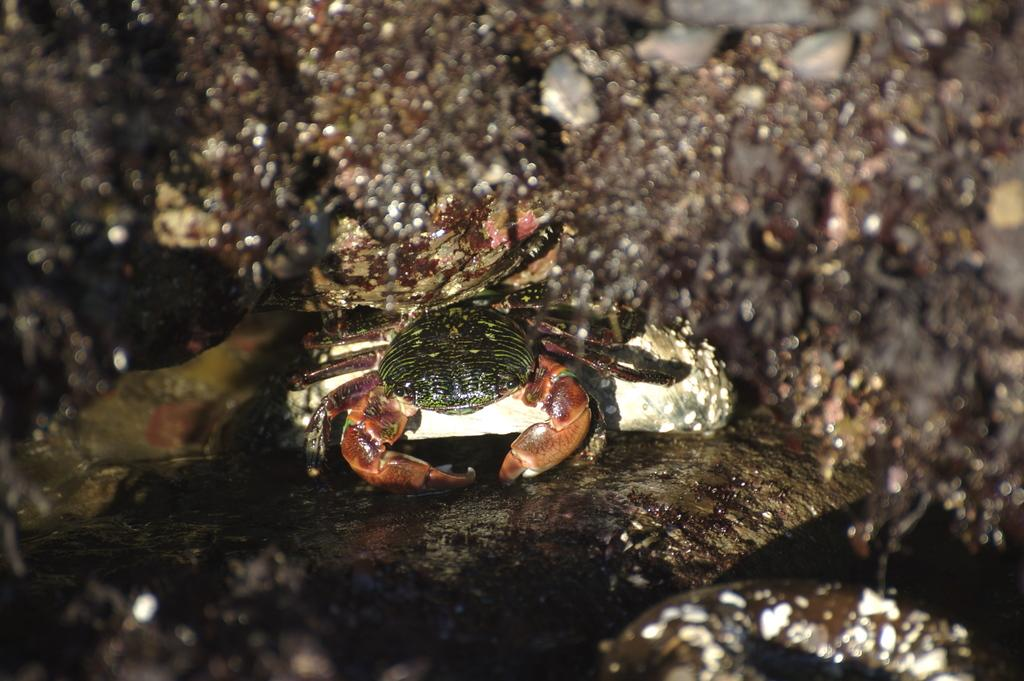What is the main subject of the image? The main subject of the image is a crab. Where is the crab located in the image? The crab is on a rock. Can you describe the background of the image? The background of the image is blurred. What type of yoke is being used by the crab in the image? There is no yoke present in the image, as it features a crab on a rock. What type of produce can be seen growing in the background of the image? There is no produce visible in the image, as the background is blurred. 